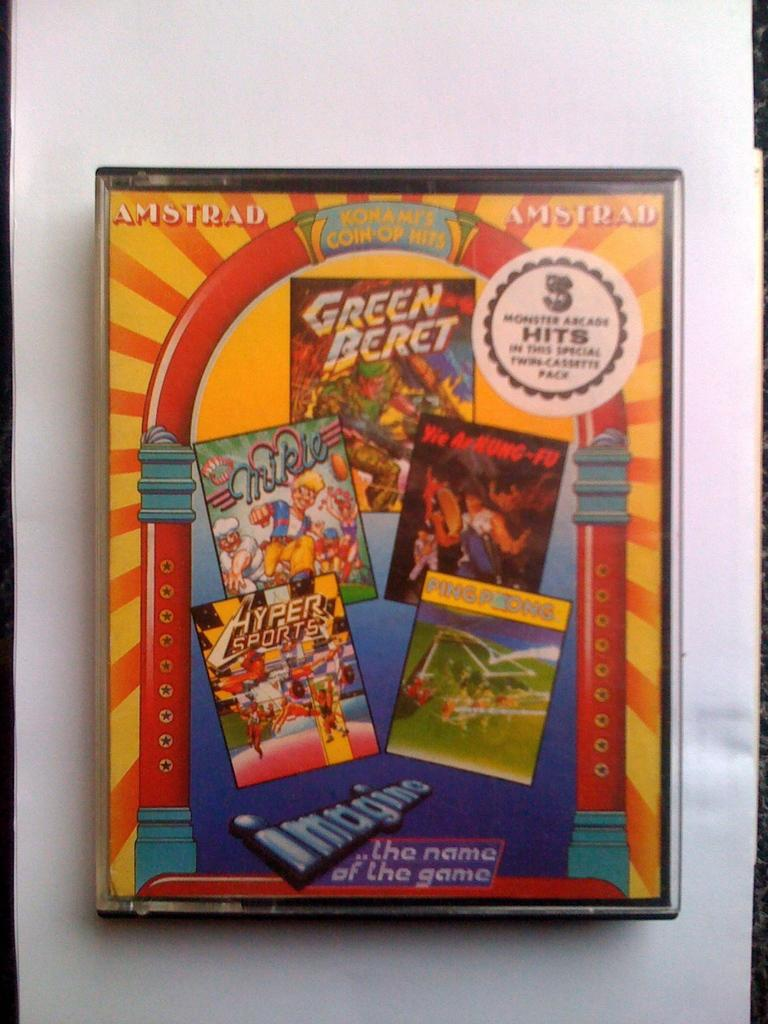What is the main object in the image? There is a colourful box in the image. What can be found on the surface of the box? There is writing on the box, and cartoon characters are also present. What is the color of the background in the image? The background of the image is white. What type of farm animal can be seen on the plate in the image? There is no plate or farm animal present in the image; it features a colourful box with writing and cartoon characters. 